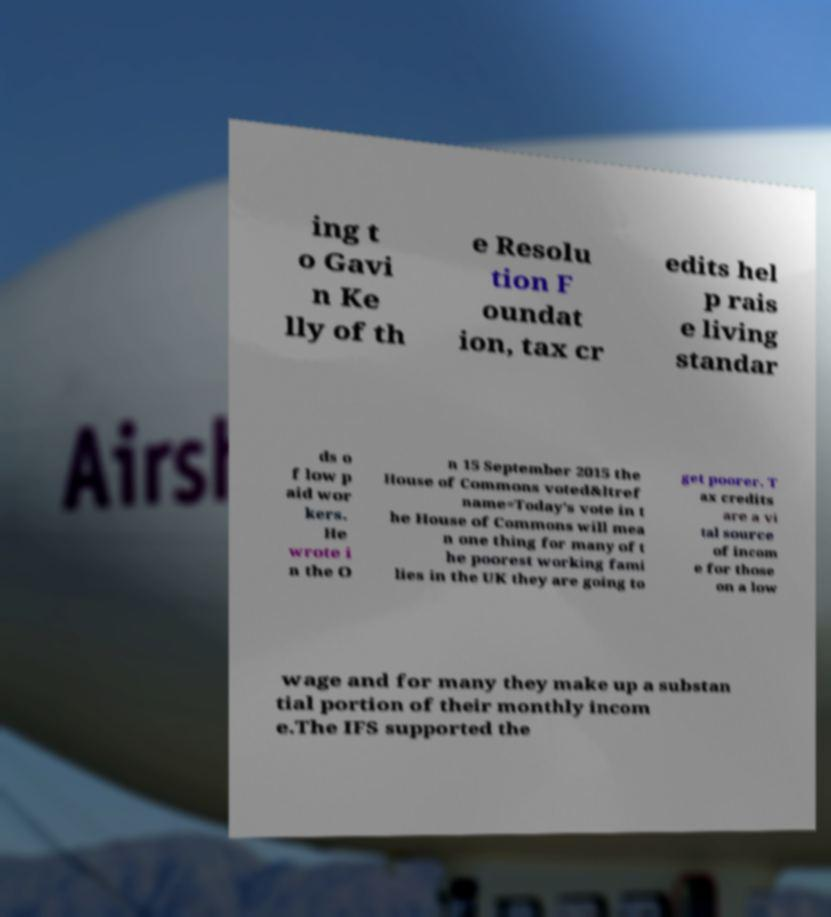I need the written content from this picture converted into text. Can you do that? ing t o Gavi n Ke lly of th e Resolu tion F oundat ion, tax cr edits hel p rais e living standar ds o f low p aid wor kers. He wrote i n the O n 15 September 2015 the House of Commons voted&ltref name=Today's vote in t he House of Commons will mea n one thing for many of t he poorest working fami lies in the UK they are going to get poorer. T ax credits are a vi tal source of incom e for those on a low wage and for many they make up a substan tial portion of their monthly incom e.The IFS supported the 